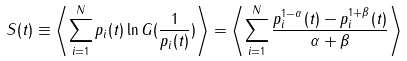<formula> <loc_0><loc_0><loc_500><loc_500>S ( t ) \equiv \left \langle \sum _ { i = 1 } ^ { N } p _ { i } ( t ) \ln G ( \frac { 1 } { p _ { i } ( t ) } ) \right \rangle = \left \langle \sum _ { i = 1 } ^ { N } \frac { p _ { i } ^ { 1 - \alpha } ( t ) - p _ { i } ^ { 1 + \beta } ( t ) } { \alpha + \beta } \right \rangle</formula> 